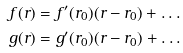Convert formula to latex. <formula><loc_0><loc_0><loc_500><loc_500>f ( r ) & = f ^ { \prime } ( r _ { 0 } ) ( r - r _ { 0 } ) + \dots \\ g ( r ) & = g ^ { \prime } ( r _ { 0 } ) ( r - r _ { 0 } ) + \dots</formula> 